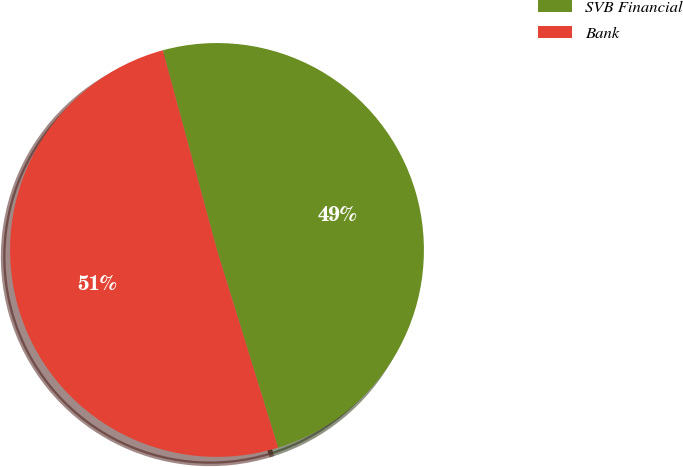<chart> <loc_0><loc_0><loc_500><loc_500><pie_chart><fcel>SVB Financial<fcel>Bank<nl><fcel>49.45%<fcel>50.55%<nl></chart> 